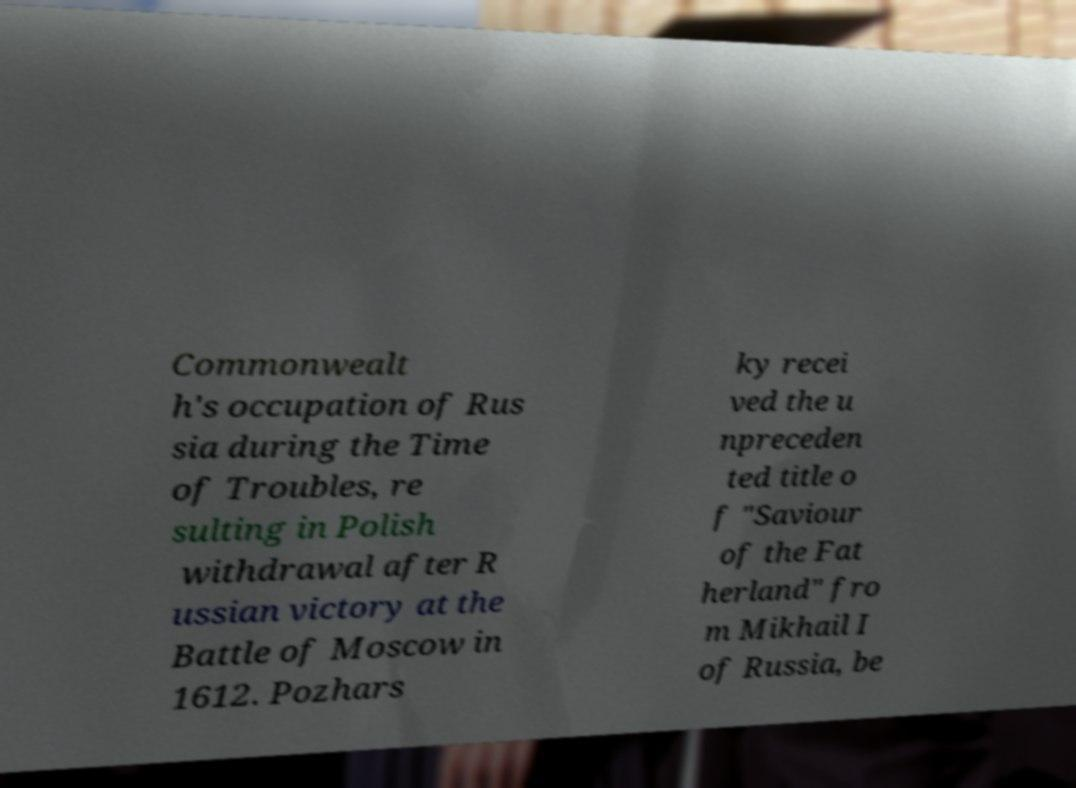Please read and relay the text visible in this image. What does it say? Commonwealt h's occupation of Rus sia during the Time of Troubles, re sulting in Polish withdrawal after R ussian victory at the Battle of Moscow in 1612. Pozhars ky recei ved the u npreceden ted title o f "Saviour of the Fat herland" fro m Mikhail I of Russia, be 